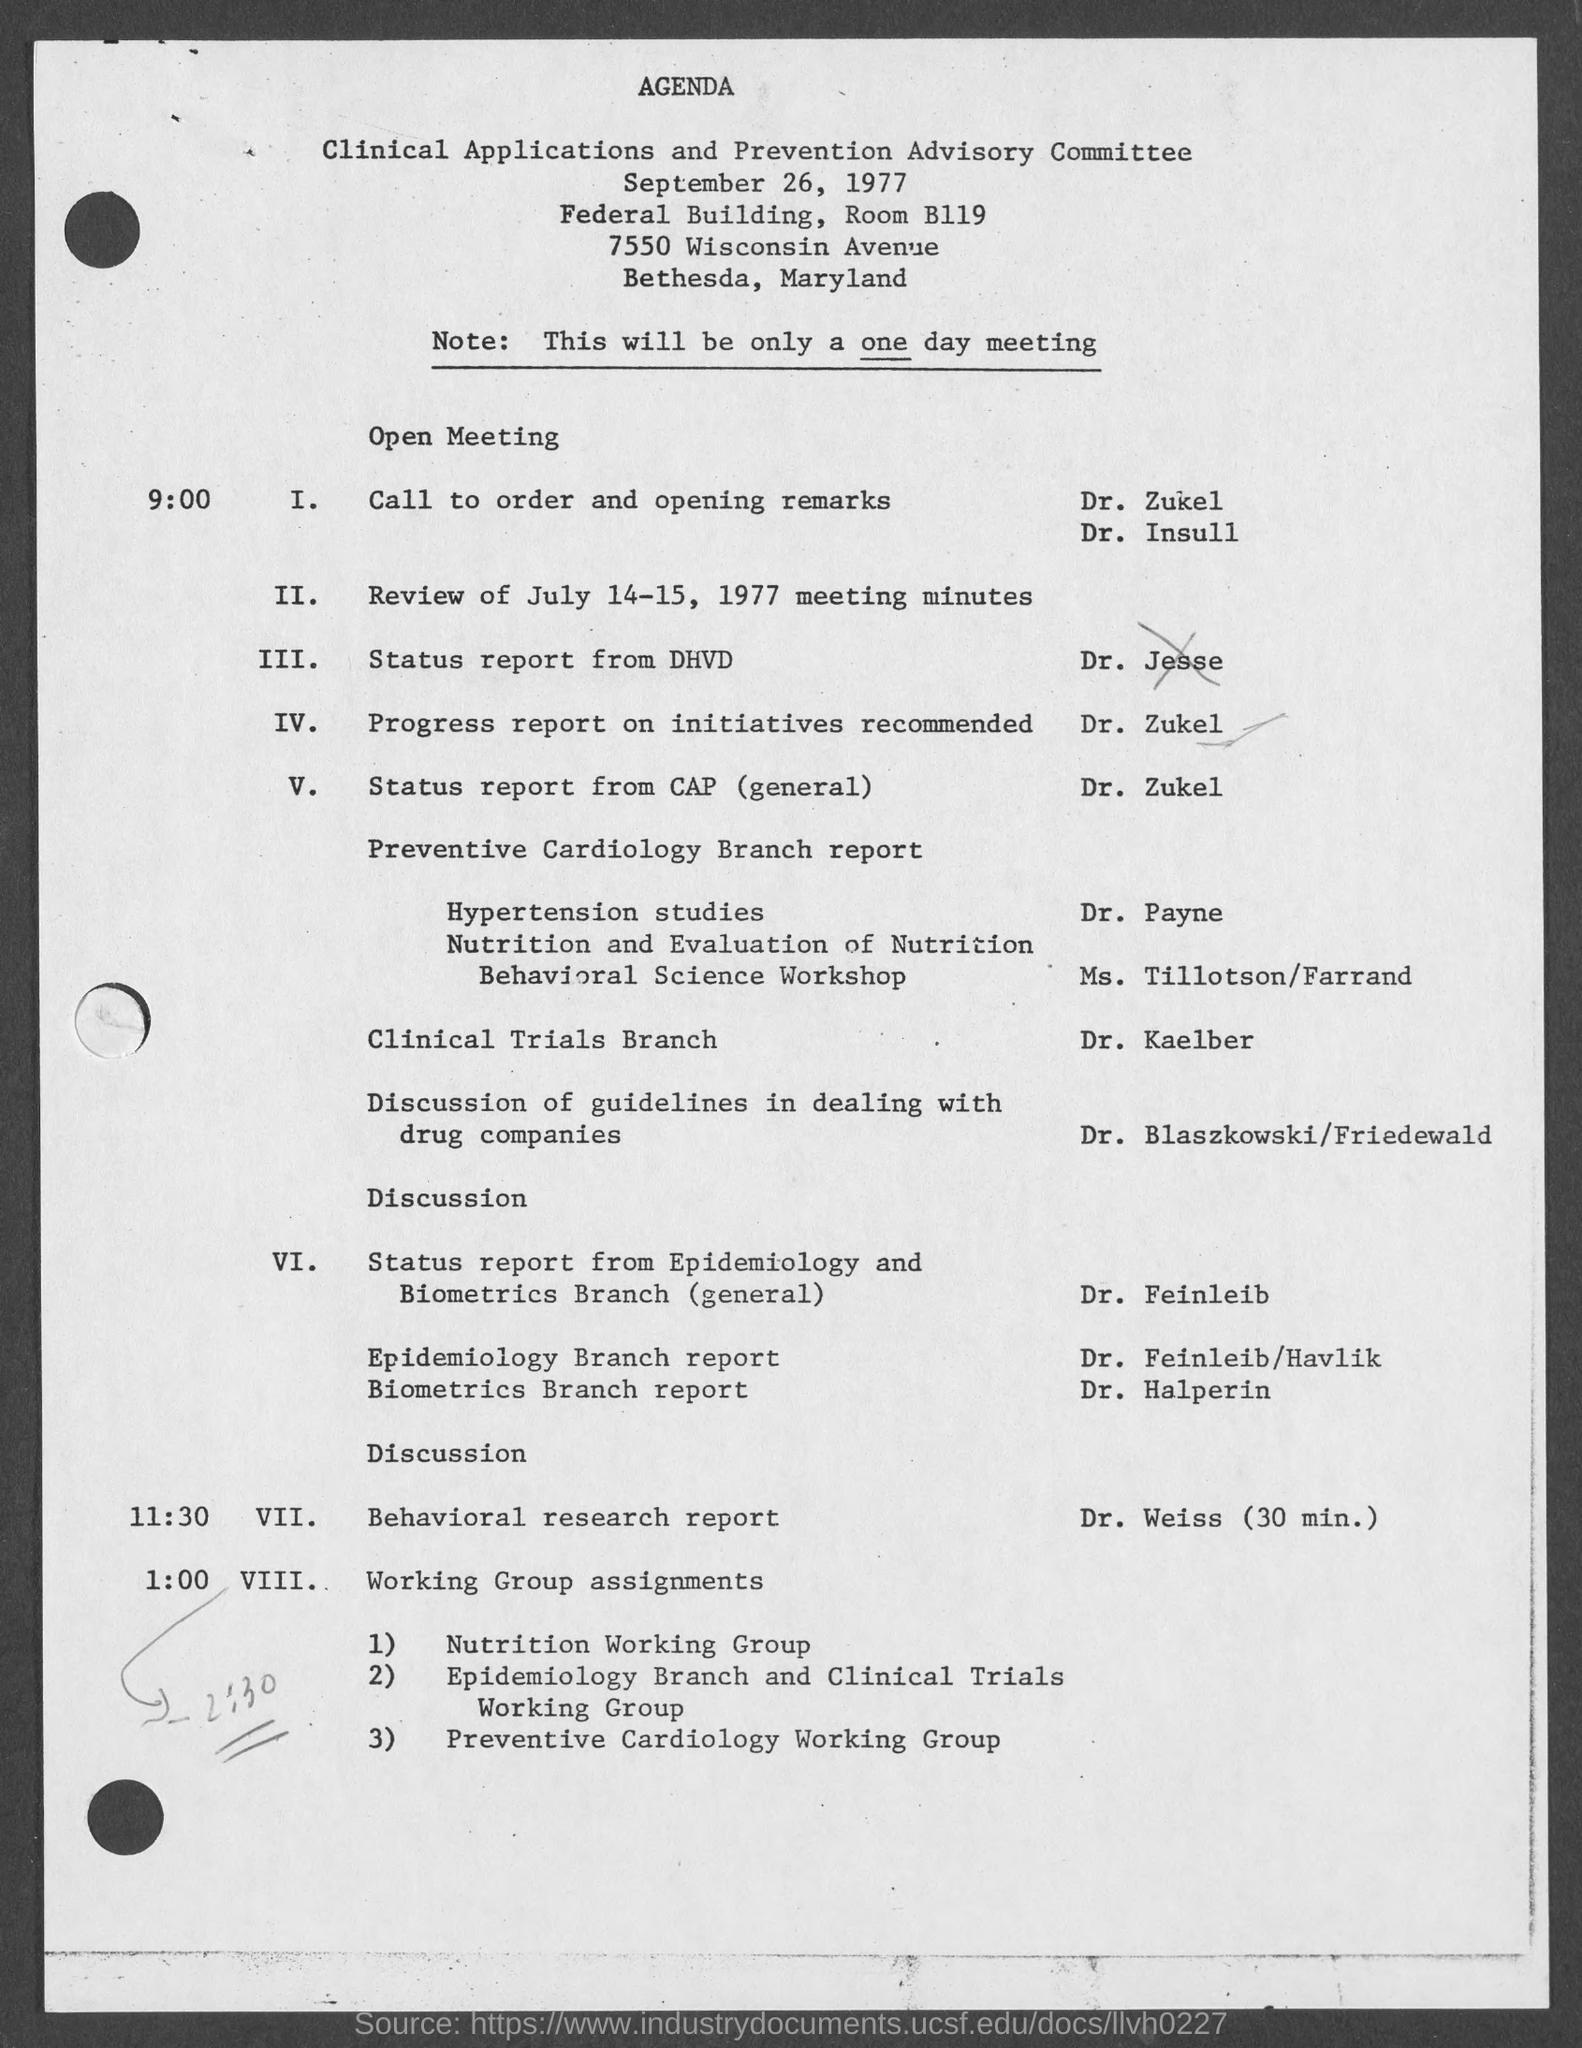Mention a couple of crucial points in this snapshot. The meeting will be held on September 26, 1977. The meeting will take place at the Federal Building in Room B119. 